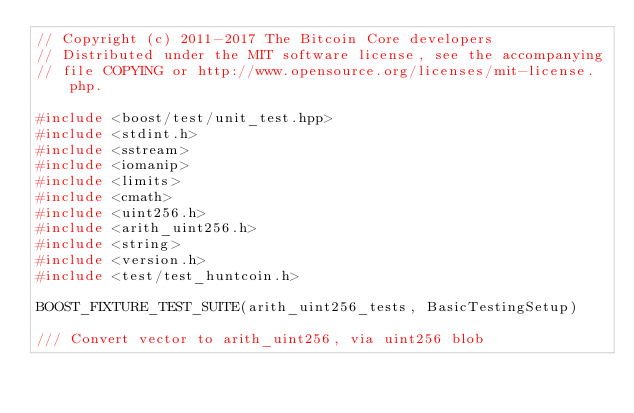Convert code to text. <code><loc_0><loc_0><loc_500><loc_500><_C++_>// Copyright (c) 2011-2017 The Bitcoin Core developers
// Distributed under the MIT software license, see the accompanying
// file COPYING or http://www.opensource.org/licenses/mit-license.php.

#include <boost/test/unit_test.hpp>
#include <stdint.h>
#include <sstream>
#include <iomanip>
#include <limits>
#include <cmath>
#include <uint256.h>
#include <arith_uint256.h>
#include <string>
#include <version.h>
#include <test/test_huntcoin.h>

BOOST_FIXTURE_TEST_SUITE(arith_uint256_tests, BasicTestingSetup)

/// Convert vector to arith_uint256, via uint256 blob</code> 